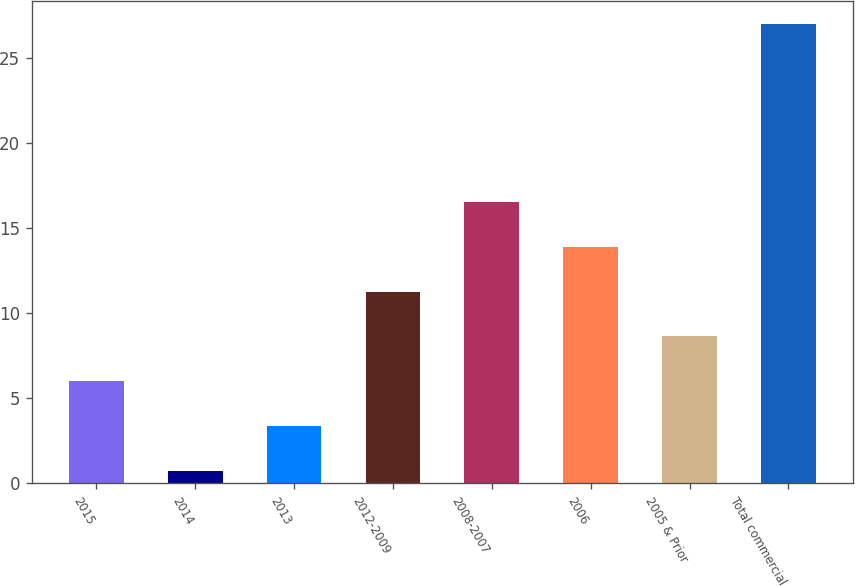Convert chart. <chart><loc_0><loc_0><loc_500><loc_500><bar_chart><fcel>2015<fcel>2014<fcel>2013<fcel>2012-2009<fcel>2008-2007<fcel>2006<fcel>2005 & Prior<fcel>Total commercial<nl><fcel>5.99<fcel>0.73<fcel>3.36<fcel>11.25<fcel>16.51<fcel>13.88<fcel>8.62<fcel>27<nl></chart> 